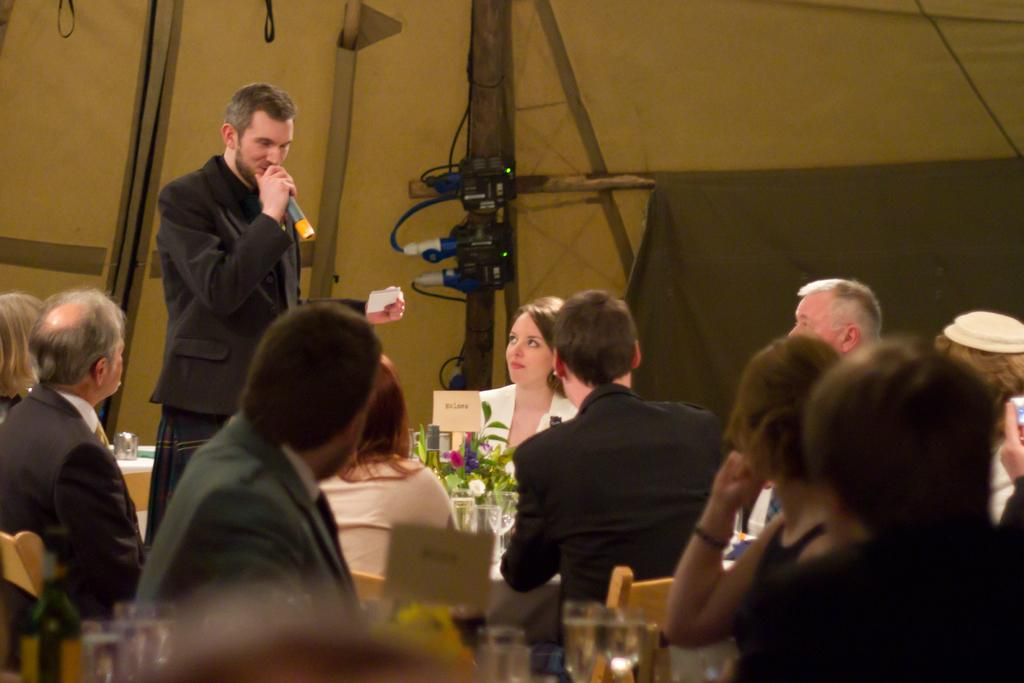How many people are in the image? There are people in the image, but the exact number is not specified. What object is used for amplifying sound in the image? There is a microphone (mike) in the image. What type of object is used for holding plants in the image? There is a flower pot in the image. What type of furniture is present in the image? There are chairs in the image. What type of tableware is present in the image? There are glasses in the image. What type of electronic device is present in the image? There is an electronic gadget in the image. What other objects are present in the image? There are other objects in the image, but their specific nature is not specified. Can you tell me how many horses are depicted in the image? There are no horses depicted in the image; the provided facts mention people, a microphone, a flower pot, chairs, glasses, an electronic gadget, and other objects, but no horses. 